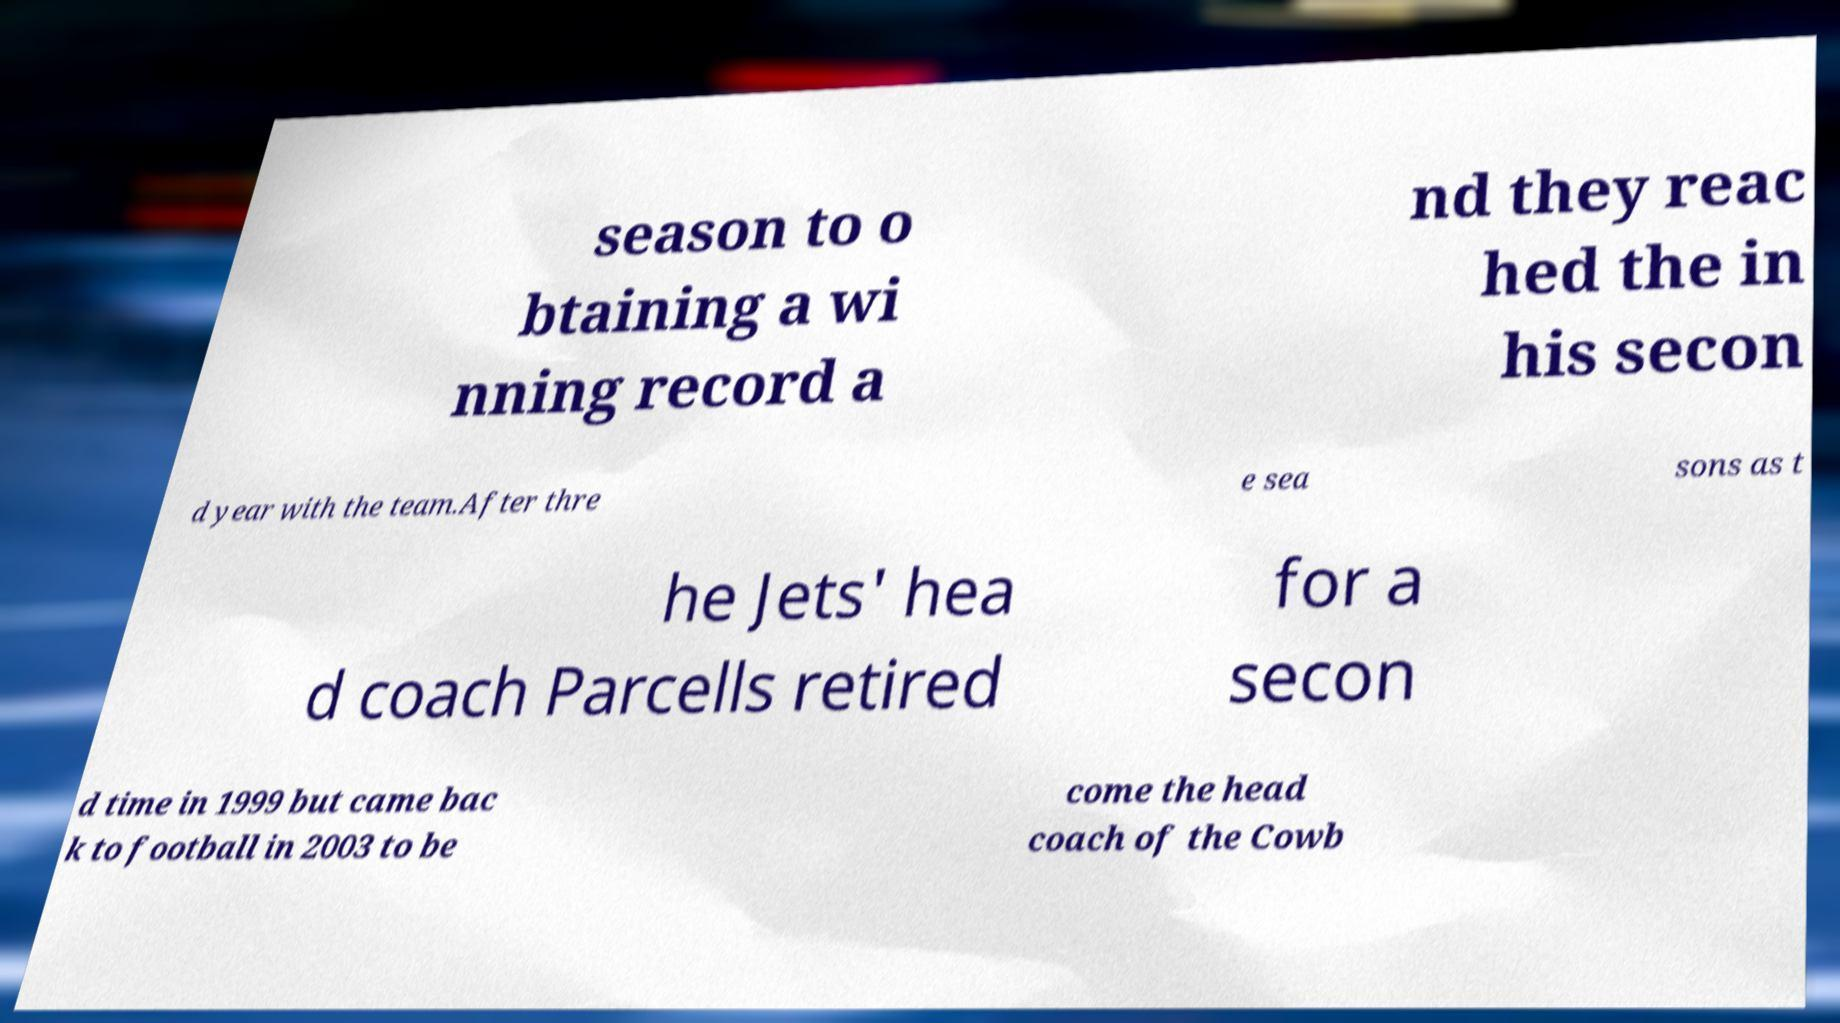Please read and relay the text visible in this image. What does it say? season to o btaining a wi nning record a nd they reac hed the in his secon d year with the team.After thre e sea sons as t he Jets' hea d coach Parcells retired for a secon d time in 1999 but came bac k to football in 2003 to be come the head coach of the Cowb 